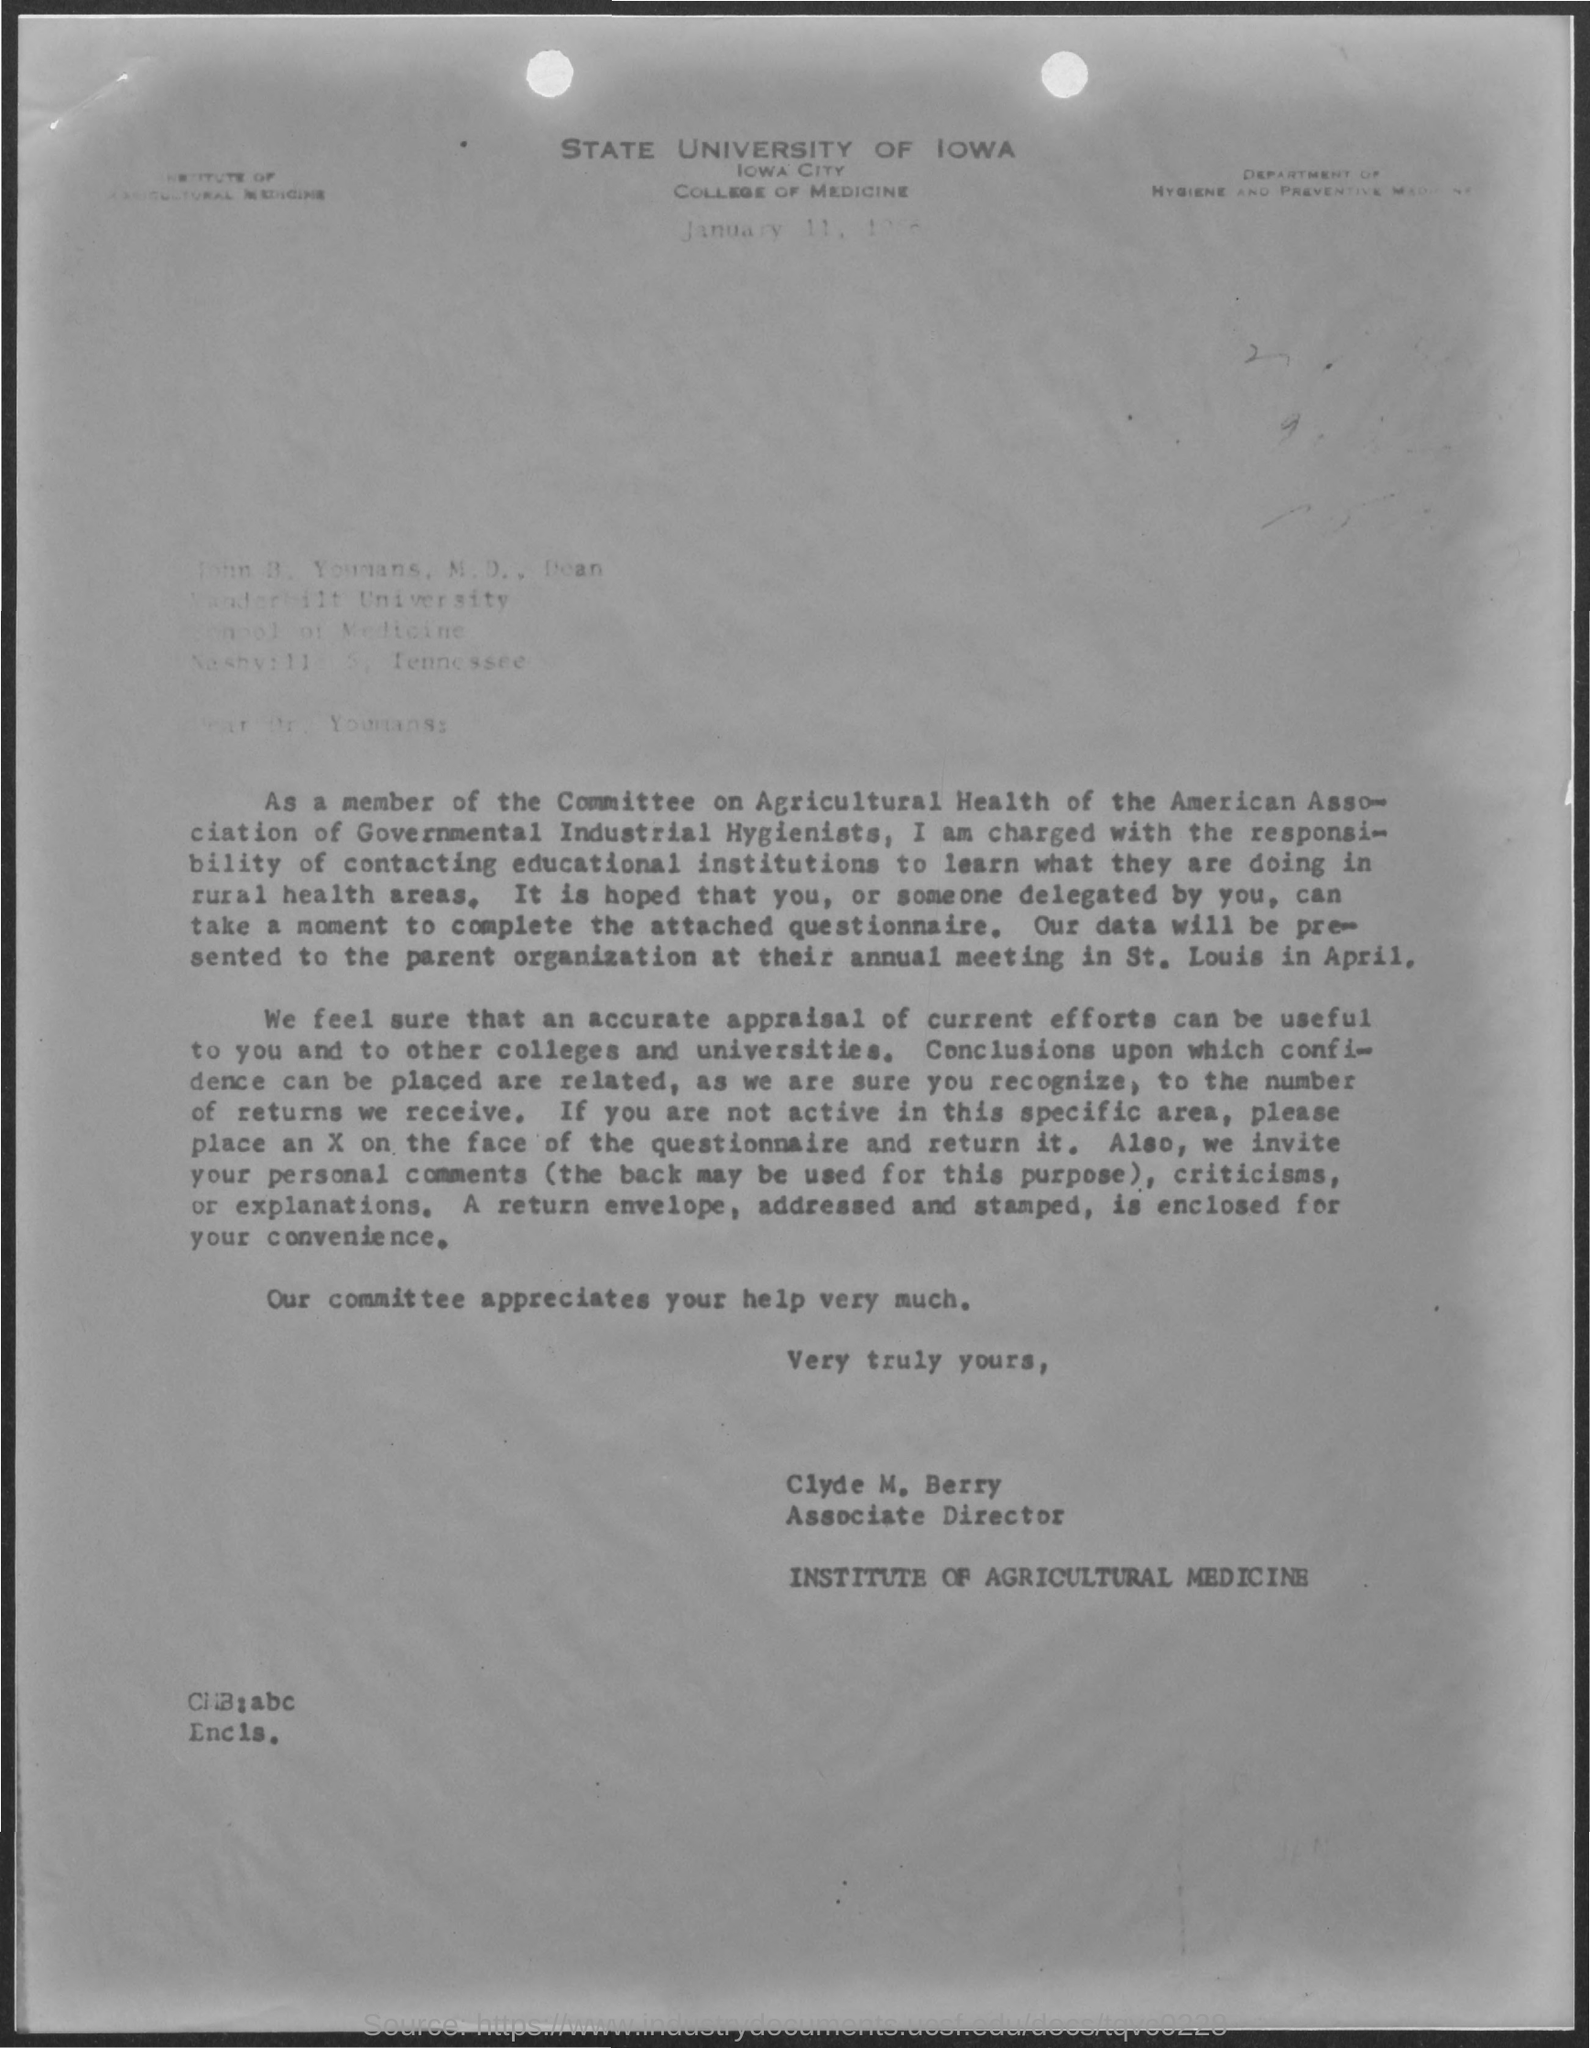Which university is mentioned?
Provide a succinct answer. STATE UNIVERSITY OF IOWA. Who is the sender?
Keep it short and to the point. CLYDE M. BERRY. What is the designation of Clyde?
Your answer should be compact. Associate Director. Which institute is Clyde part of?
Give a very brief answer. INSTITUTE OF AGRICULTURAL MEDICINE. 